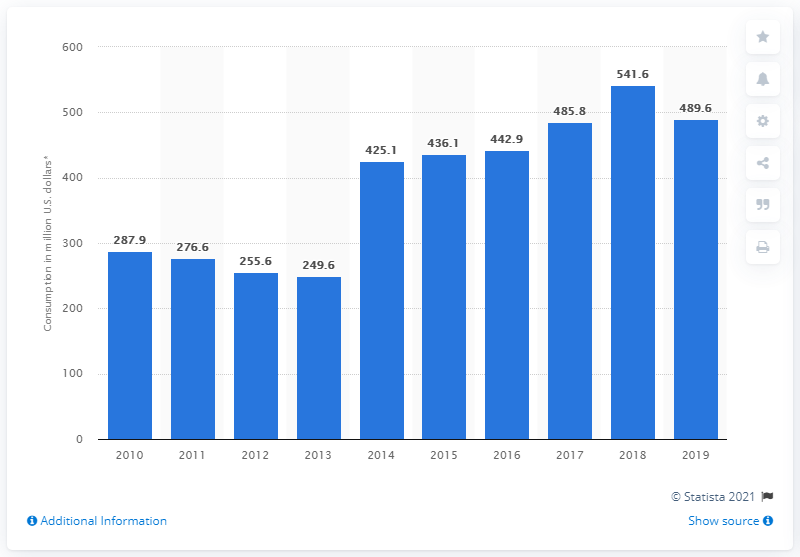Highlight a few significant elements in this photo. In 2019, the tourism consumption in Grenada was 489.6 million dollars. 